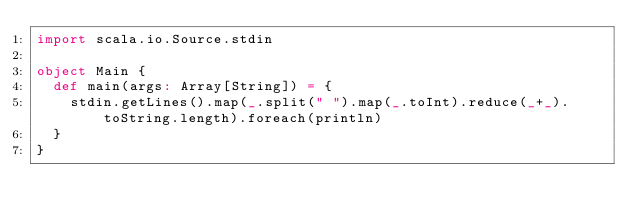Convert code to text. <code><loc_0><loc_0><loc_500><loc_500><_Scala_>import scala.io.Source.stdin

object Main {
  def main(args: Array[String]) = {
    stdin.getLines().map(_.split(" ").map(_.toInt).reduce(_+_).toString.length).foreach(println)
  }
}</code> 